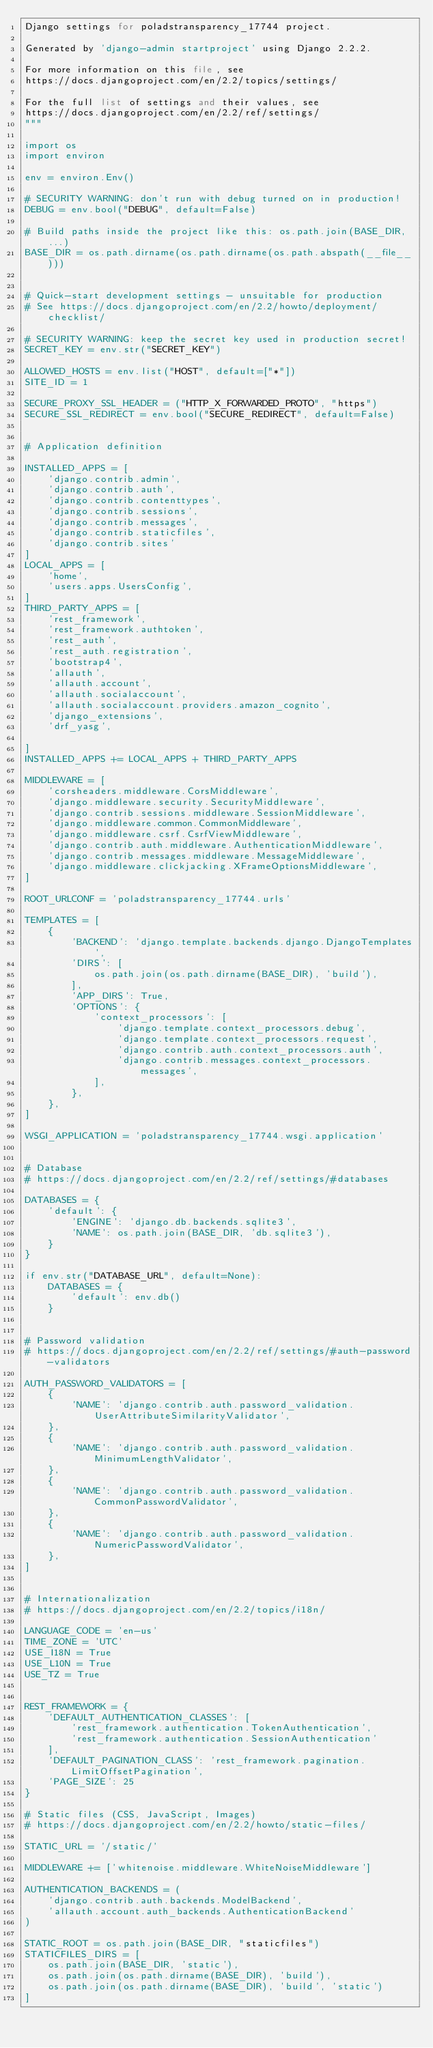<code> <loc_0><loc_0><loc_500><loc_500><_Python_>Django settings for poladstransparency_17744 project.

Generated by 'django-admin startproject' using Django 2.2.2.

For more information on this file, see
https://docs.djangoproject.com/en/2.2/topics/settings/

For the full list of settings and their values, see
https://docs.djangoproject.com/en/2.2/ref/settings/
"""

import os
import environ

env = environ.Env()

# SECURITY WARNING: don't run with debug turned on in production!
DEBUG = env.bool("DEBUG", default=False)

# Build paths inside the project like this: os.path.join(BASE_DIR, ...)
BASE_DIR = os.path.dirname(os.path.dirname(os.path.abspath(__file__)))


# Quick-start development settings - unsuitable for production
# See https://docs.djangoproject.com/en/2.2/howto/deployment/checklist/

# SECURITY WARNING: keep the secret key used in production secret!
SECRET_KEY = env.str("SECRET_KEY")

ALLOWED_HOSTS = env.list("HOST", default=["*"])
SITE_ID = 1

SECURE_PROXY_SSL_HEADER = ("HTTP_X_FORWARDED_PROTO", "https")
SECURE_SSL_REDIRECT = env.bool("SECURE_REDIRECT", default=False)


# Application definition

INSTALLED_APPS = [
    'django.contrib.admin',
    'django.contrib.auth',
    'django.contrib.contenttypes',
    'django.contrib.sessions',
    'django.contrib.messages',
    'django.contrib.staticfiles',
    'django.contrib.sites'
]
LOCAL_APPS = [
    'home',
    'users.apps.UsersConfig',
]
THIRD_PARTY_APPS = [
    'rest_framework',
    'rest_framework.authtoken',
    'rest_auth',
    'rest_auth.registration',
    'bootstrap4',
    'allauth',
    'allauth.account',
    'allauth.socialaccount',
    'allauth.socialaccount.providers.amazon_cognito',
    'django_extensions',
    'drf_yasg',

]
INSTALLED_APPS += LOCAL_APPS + THIRD_PARTY_APPS

MIDDLEWARE = [
    'corsheaders.middleware.CorsMiddleware',
    'django.middleware.security.SecurityMiddleware',
    'django.contrib.sessions.middleware.SessionMiddleware',
    'django.middleware.common.CommonMiddleware',
    'django.middleware.csrf.CsrfViewMiddleware',
    'django.contrib.auth.middleware.AuthenticationMiddleware',
    'django.contrib.messages.middleware.MessageMiddleware',
    'django.middleware.clickjacking.XFrameOptionsMiddleware',
]

ROOT_URLCONF = 'poladstransparency_17744.urls'

TEMPLATES = [
    {
        'BACKEND': 'django.template.backends.django.DjangoTemplates',
        'DIRS': [
            os.path.join(os.path.dirname(BASE_DIR), 'build'),
        ],
        'APP_DIRS': True,
        'OPTIONS': {
            'context_processors': [
                'django.template.context_processors.debug',
                'django.template.context_processors.request',
                'django.contrib.auth.context_processors.auth',
                'django.contrib.messages.context_processors.messages',
            ],
        },
    },
]

WSGI_APPLICATION = 'poladstransparency_17744.wsgi.application'


# Database
# https://docs.djangoproject.com/en/2.2/ref/settings/#databases

DATABASES = {
    'default': {
        'ENGINE': 'django.db.backends.sqlite3',
        'NAME': os.path.join(BASE_DIR, 'db.sqlite3'),
    }
}

if env.str("DATABASE_URL", default=None):
    DATABASES = {
        'default': env.db()
    }


# Password validation
# https://docs.djangoproject.com/en/2.2/ref/settings/#auth-password-validators

AUTH_PASSWORD_VALIDATORS = [
    {
        'NAME': 'django.contrib.auth.password_validation.UserAttributeSimilarityValidator',
    },
    {
        'NAME': 'django.contrib.auth.password_validation.MinimumLengthValidator',
    },
    {
        'NAME': 'django.contrib.auth.password_validation.CommonPasswordValidator',
    },
    {
        'NAME': 'django.contrib.auth.password_validation.NumericPasswordValidator',
    },
]


# Internationalization
# https://docs.djangoproject.com/en/2.2/topics/i18n/

LANGUAGE_CODE = 'en-us'
TIME_ZONE = 'UTC'
USE_I18N = True
USE_L10N = True
USE_TZ = True


REST_FRAMEWORK = {
    'DEFAULT_AUTHENTICATION_CLASSES': [
        'rest_framework.authentication.TokenAuthentication',
        'rest_framework.authentication.SessionAuthentication'
    ],
    'DEFAULT_PAGINATION_CLASS': 'rest_framework.pagination.LimitOffsetPagination',
    'PAGE_SIZE': 25
}

# Static files (CSS, JavaScript, Images)
# https://docs.djangoproject.com/en/2.2/howto/static-files/

STATIC_URL = '/static/'

MIDDLEWARE += ['whitenoise.middleware.WhiteNoiseMiddleware']

AUTHENTICATION_BACKENDS = (
    'django.contrib.auth.backends.ModelBackend',
    'allauth.account.auth_backends.AuthenticationBackend'
)

STATIC_ROOT = os.path.join(BASE_DIR, "staticfiles")
STATICFILES_DIRS = [
    os.path.join(BASE_DIR, 'static'),
    os.path.join(os.path.dirname(BASE_DIR), 'build'),
    os.path.join(os.path.dirname(BASE_DIR), 'build', 'static')
]</code> 